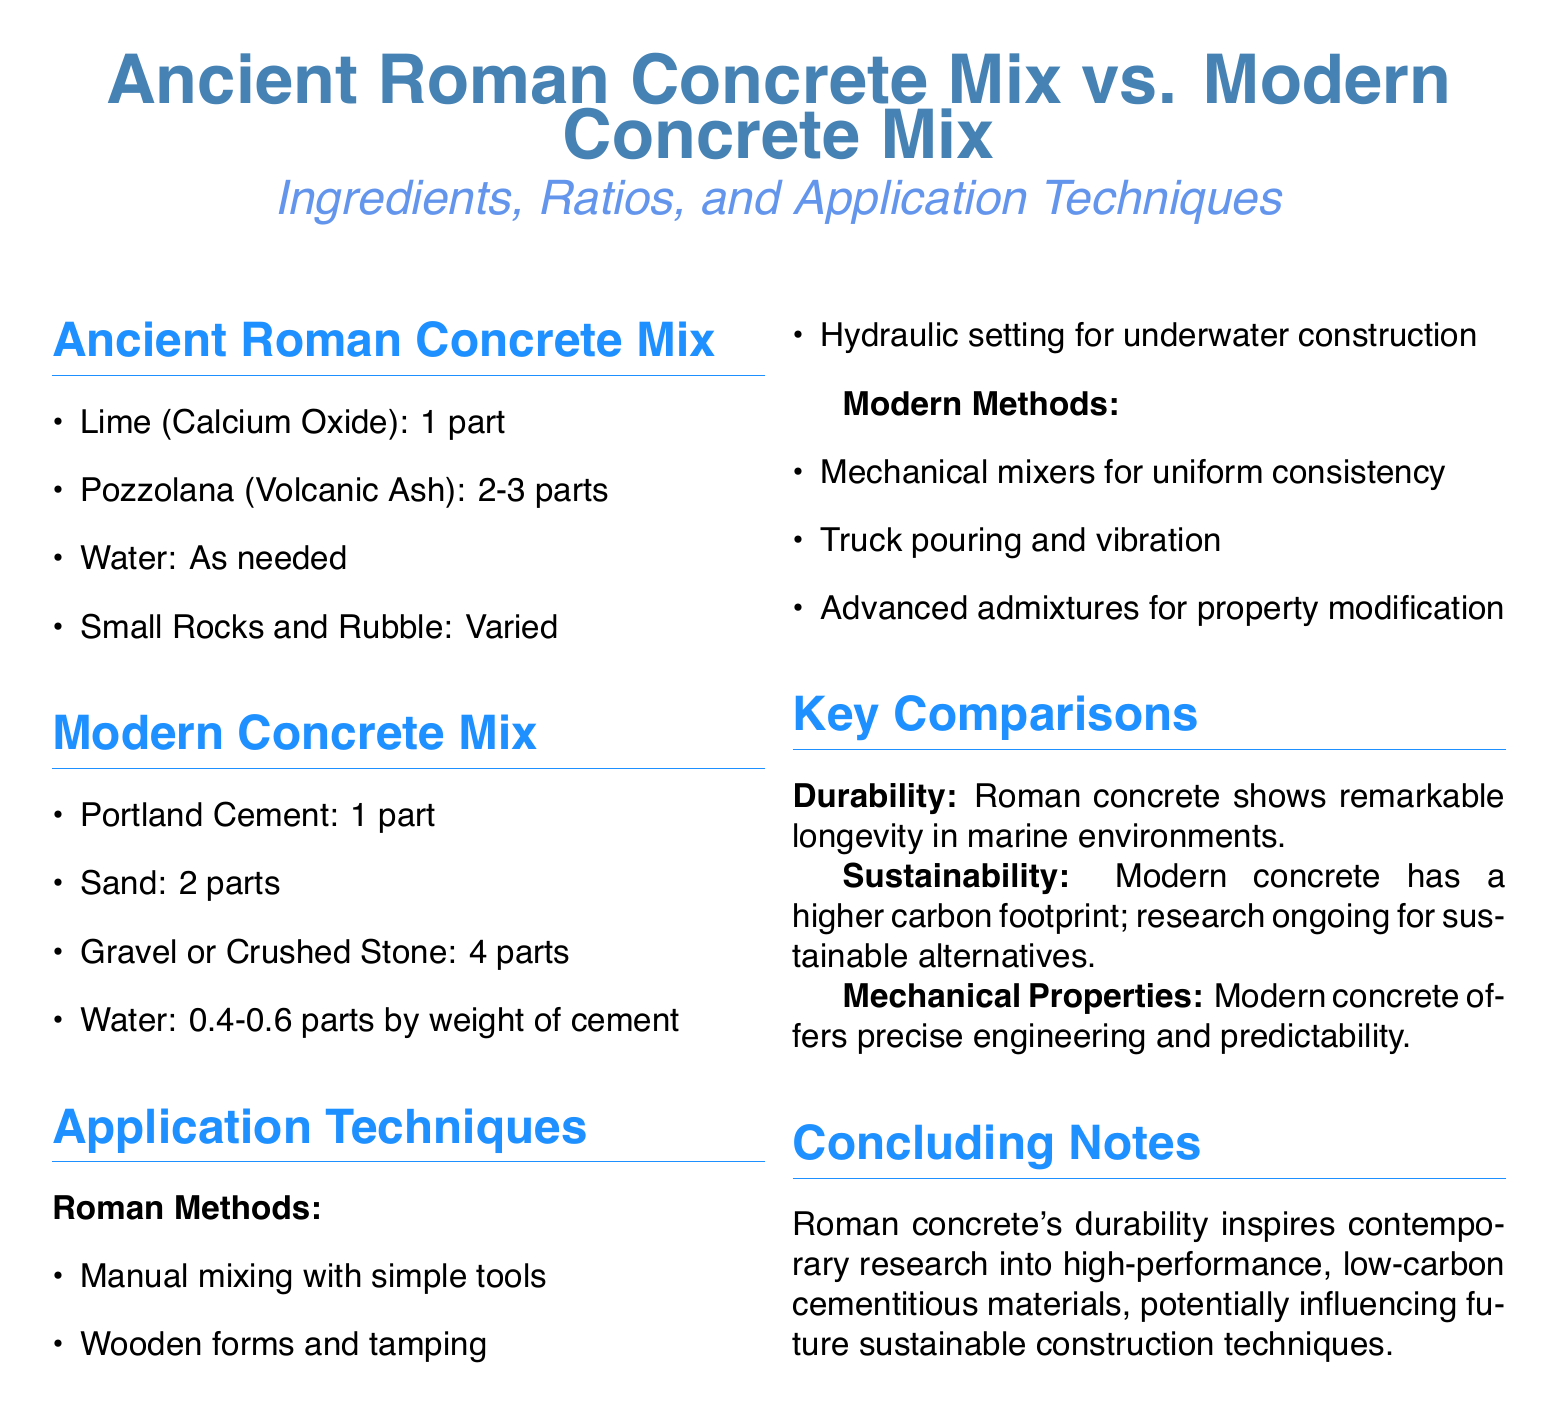What are the main ingredients in Ancient Roman concrete? The primary ingredients listed for Ancient Roman concrete are lime, pozzolana, water, and small rocks and rubble.
Answer: Lime, Pozzolana, Water, Small Rocks What is the ratio of Portland cement to sand in modern concrete mix? The document specifies a ratio of 1 part Portland cement to 2 parts sand in modern concrete mix.
Answer: 1:2 What type of mixing methods were used in Ancient Roman concrete application? The document states that Ancient Roman concrete used manual mixing with simple tools as a technique.
Answer: Manual mixing What is a significant property of Roman concrete in marine environments? According to the document, Roman concrete shows notable durability, particularly in marine settings.
Answer: Durability What advanced materials do modern methods use? The document mentions that modern methods employ advanced admixtures for property modification.
Answer: Admixtures What is a comparison noted for the carbon footprint between Roman and modern concrete? The document indicates that modern concrete has a higher carbon footprint compared to Roman concrete.
Answer: Higher carbon footprint What is one application technique that differs between Roman and modern methods? The methods of application for Roman concrete include simple wooden forms, whereas modern methods utilize mechanical mixers.
Answer: Mechanical mixers How many parts of pozzolana are used in the Ancient Roman concrete mix? The document states that the quantity of pozzolana used in Ancient Roman concrete mix is 2 to 3 parts.
Answer: 2-3 parts 